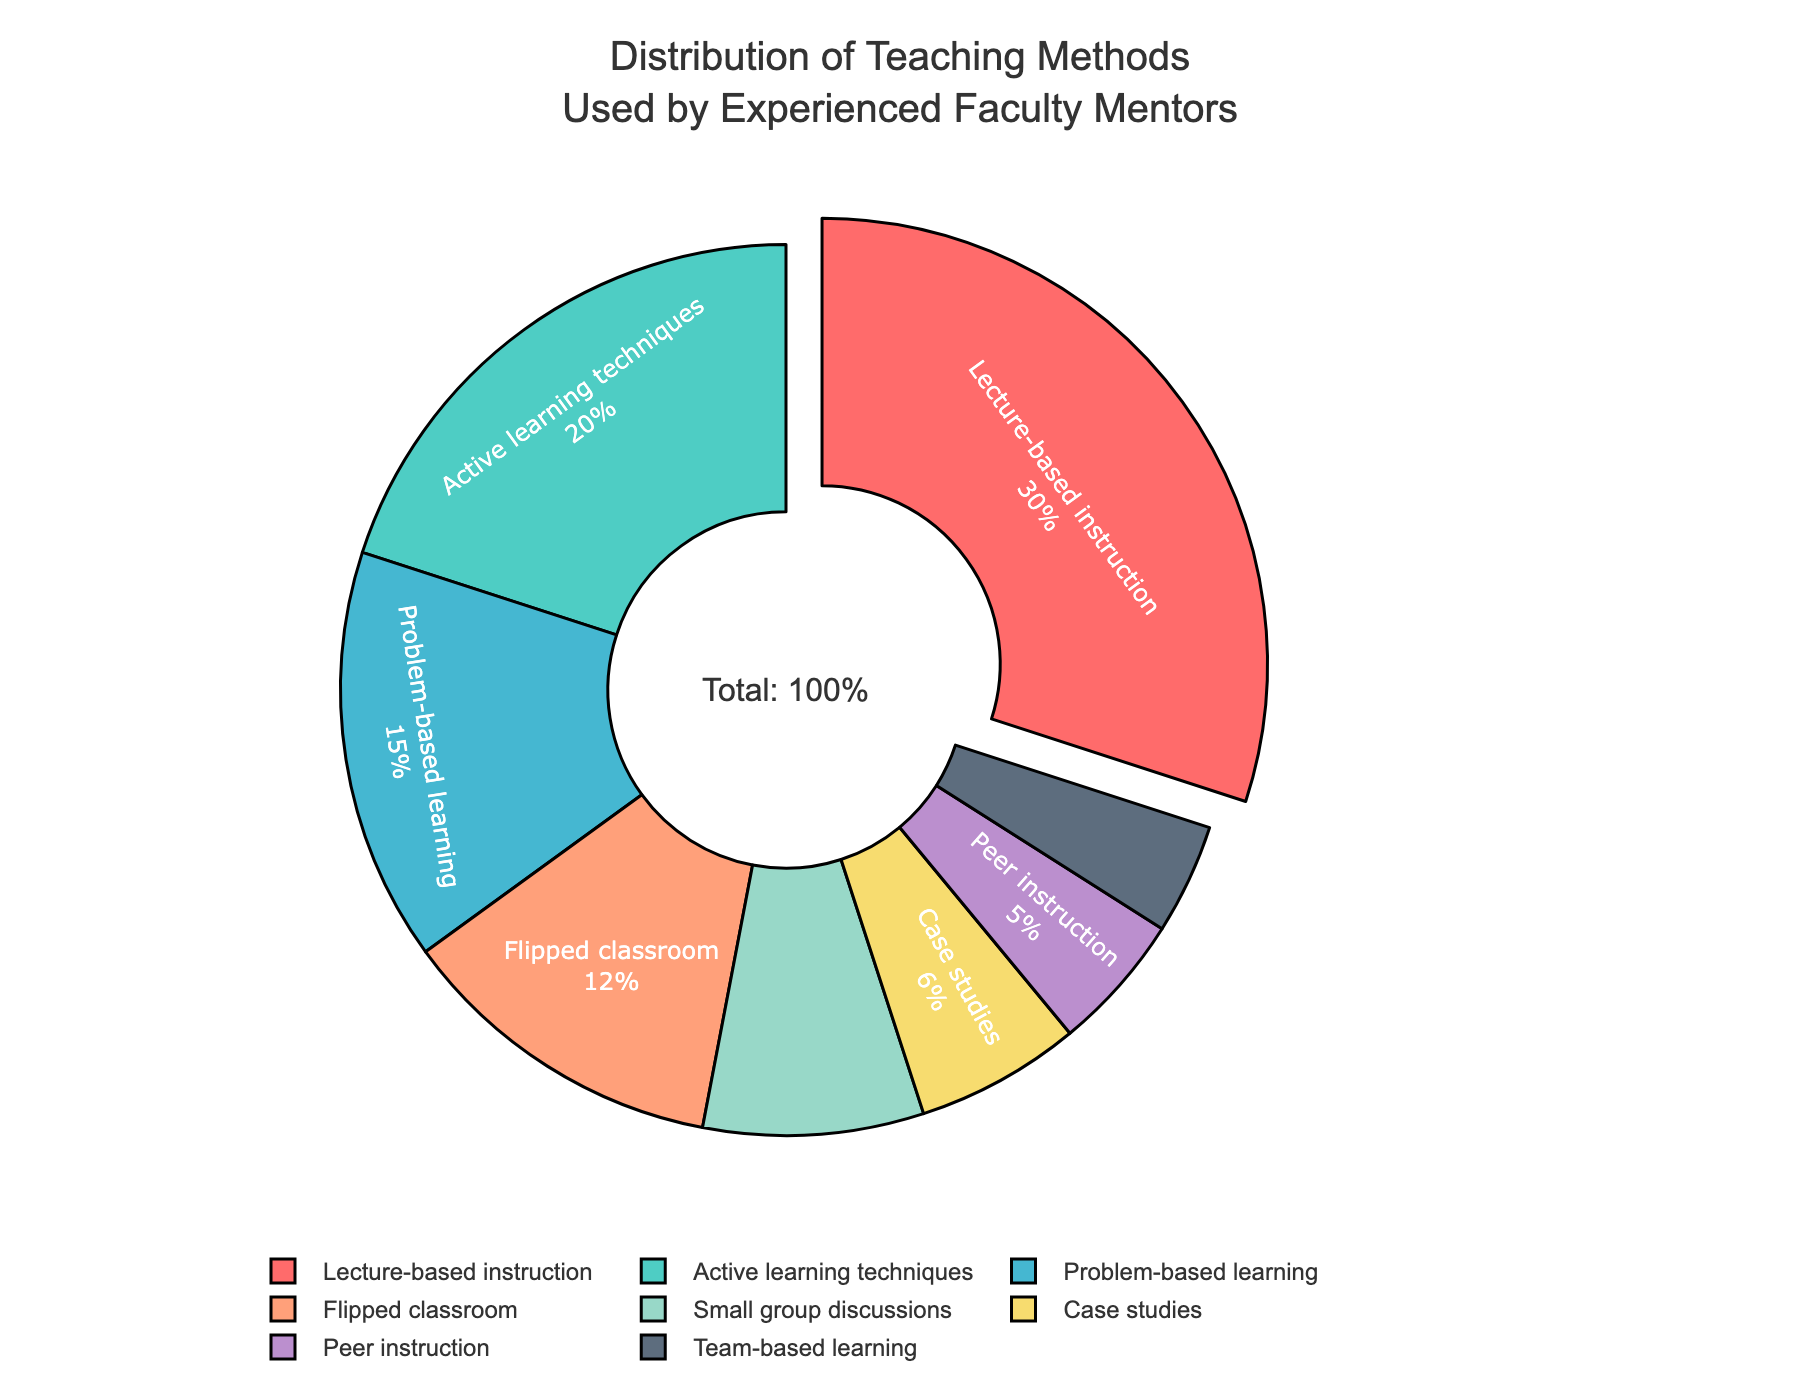Which teaching method is used the most by experienced faculty mentors? By looking at the pie chart, the largest section represents the teaching method used the most. The segment for Lecture-based instruction is the largest, indicating it is used the most.
Answer: Lecture-based instruction Which teaching method has the smallest percentage in the distribution? The smallest section of the pie chart represents the teaching method with the smallest percentage. The segment for Team-based learning is the smallest.
Answer: Team-based learning What is the combined percentage of Problem-based learning and Case studies? The percentage for Problem-based learning is 15%, and for Case studies it is 6%. Adding these gives 15% + 6% = 21%.
Answer: 21% Which teaching method is more prevalent: Flipped classroom or Small group discussions? By comparing the size of the pie segments, Flipped classroom occupies a larger portion than Small group discussions.
Answer: Flipped classroom What is the total percentage of Active learning techniques, Flipped classroom, and Peer instruction combined? Adding the percentages of Active learning techniques (20%), Flipped classroom (12%), and Peer instruction (5%) gives 20% + 12% + 5% = 37%.
Answer: 37% How does the percentage of Lecture-based instruction compare to the sum of Team-based learning and Peer instruction? The percentage for Lecture-based instruction is 30%. Summing Team-based learning (4%) and Peer instruction (5%) gives 4% + 5% = 9%. Lecture-based instruction (30%) is greater than the sum (9%).
Answer: Greater What color represents Peer instruction in the pie chart? Peer instruction is represented by looking at the specific color for its section in the pie chart. It appears in a light purple or lavender color.
Answer: Light purple/Lavender What teaching methods have a combined percentage equal to or greater than 50%? Adding the percentages of methods starting from the largest until reaching 50% or more: 
- Lecture-based instruction (30%)
- Active learning techniques (20%)
Sum: 30% + 20% = 50%. 
No more methods need to be added as this sum is already 50%.
Answer: Lecture-based instruction, Active learning techniques 